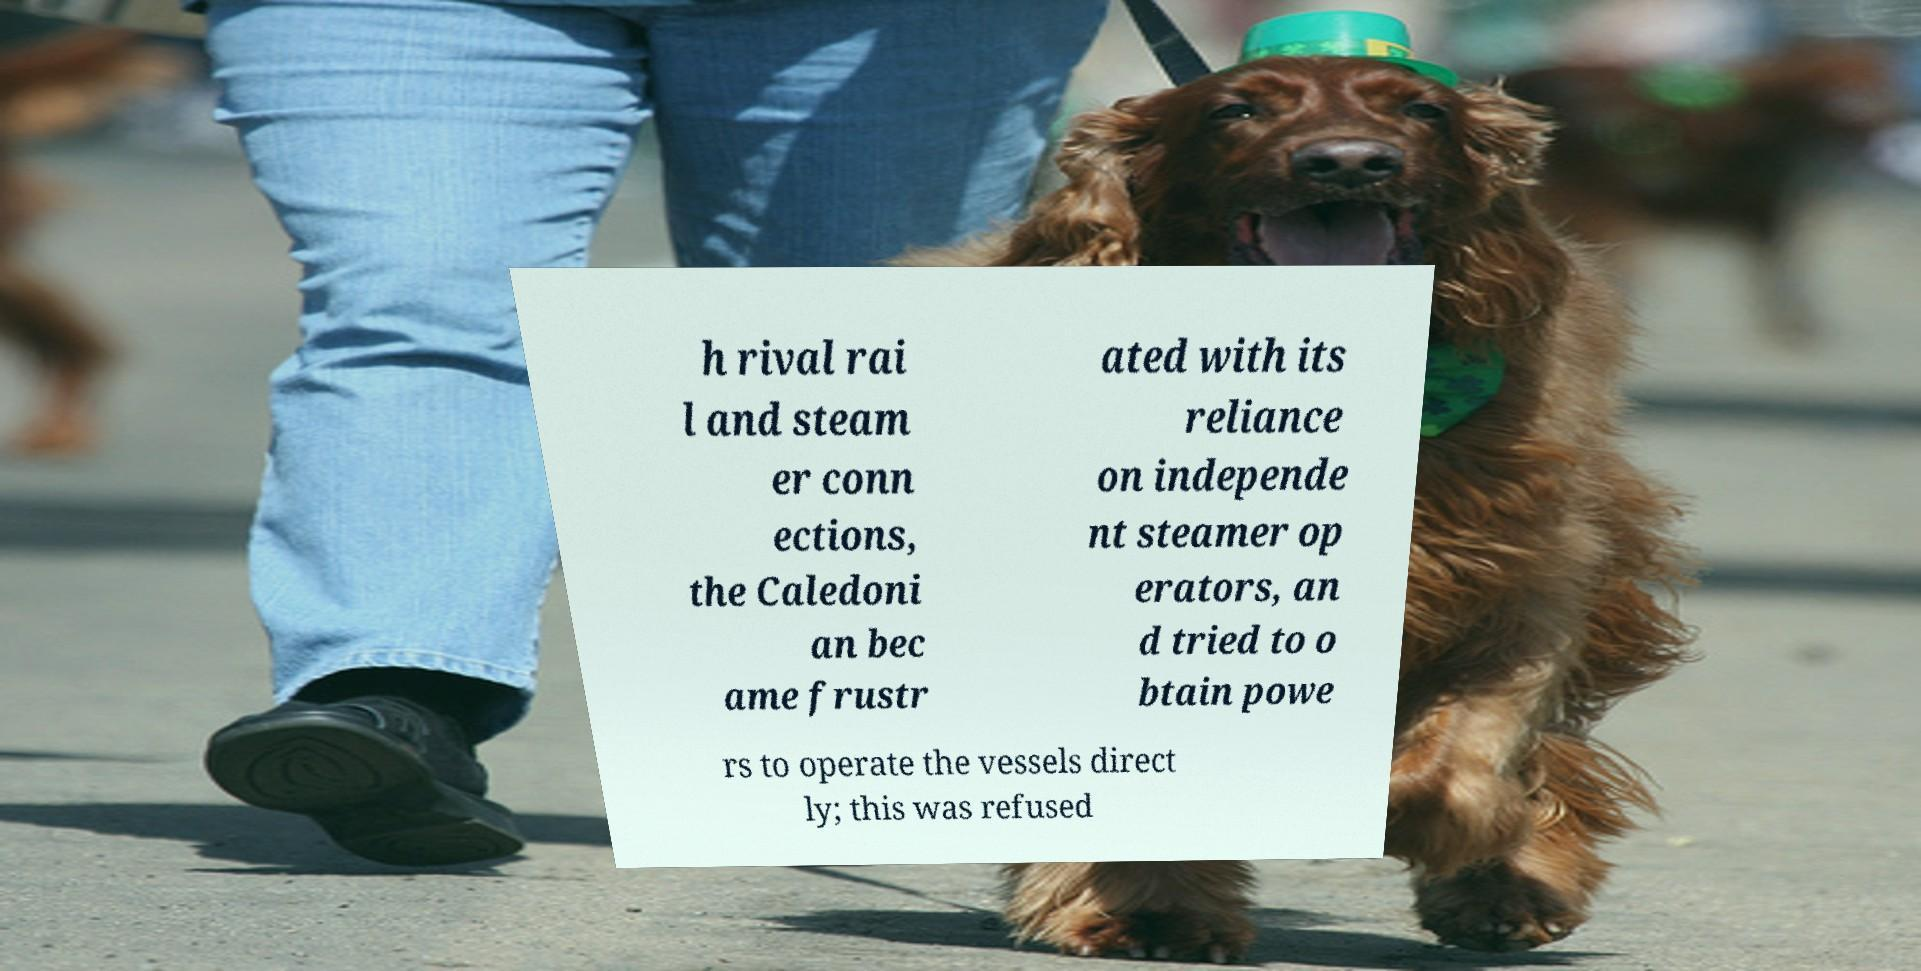Please identify and transcribe the text found in this image. h rival rai l and steam er conn ections, the Caledoni an bec ame frustr ated with its reliance on independe nt steamer op erators, an d tried to o btain powe rs to operate the vessels direct ly; this was refused 